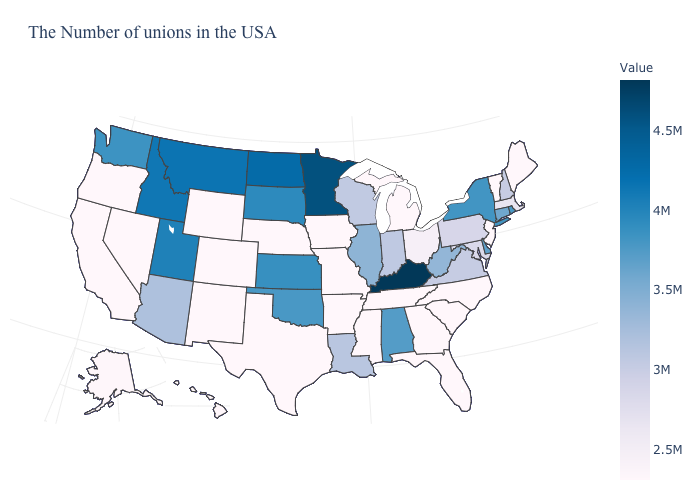Does the map have missing data?
Be succinct. No. Which states have the lowest value in the Northeast?
Short answer required. Maine, Vermont. Is the legend a continuous bar?
Keep it brief. Yes. Among the states that border North Dakota , which have the highest value?
Concise answer only. Minnesota. Does the map have missing data?
Quick response, please. No. Which states have the highest value in the USA?
Keep it brief. Kentucky. 